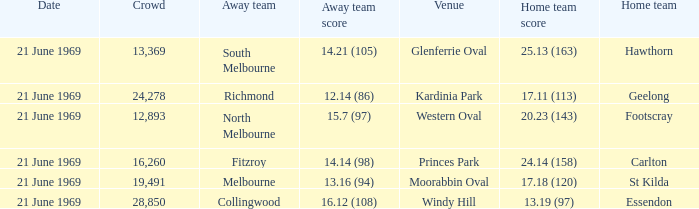When did an away team score 15.7 (97)? 21 June 1969. 